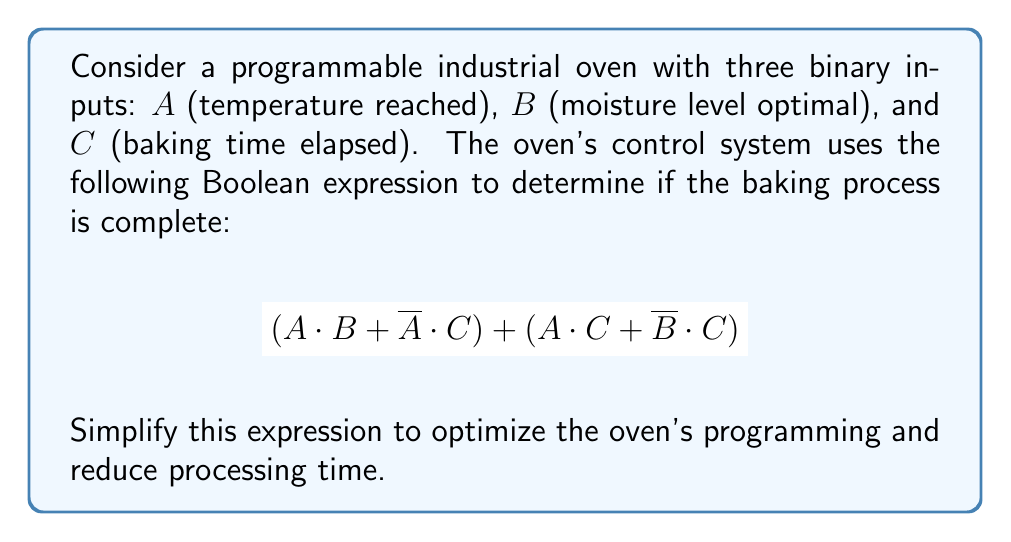Can you answer this question? Let's simplify the expression step by step:

1) First, let's distribute the terms:
   $$(A \cdot B + \overline{A} \cdot C) + (A \cdot C + \overline{B} \cdot C)$$

2) We can rearrange the terms using the commutative property:
   $$A \cdot B + \overline{A} \cdot C + A \cdot C + \overline{B} \cdot C$$

3) Now, let's group the terms with C:
   $$A \cdot B + (\overline{A} \cdot C + A \cdot C) + \overline{B} \cdot C$$

4) The middle group $(\overline{A} \cdot C + A \cdot C)$ can be simplified using the distributive property:
   $$A \cdot B + (\overline{A} + A) \cdot C + \overline{B} \cdot C$$

5) $\overline{A} + A = 1$ (law of excluded middle), so we have:
   $$A \cdot B + C + \overline{B} \cdot C$$

6) Now we can factor out C:
   $$A \cdot B + C \cdot (1 + \overline{B})$$

7) $(1 + \overline{B}) = 1$ (law of absorption), so our final simplified expression is:
   $$A \cdot B + C$$

This simplified expression means the baking process is complete if either:
- Both temperature is reached (A) and moisture level is optimal (B), or
- The baking time has elapsed (C), regardless of temperature and moisture.
Answer: $A \cdot B + C$ 